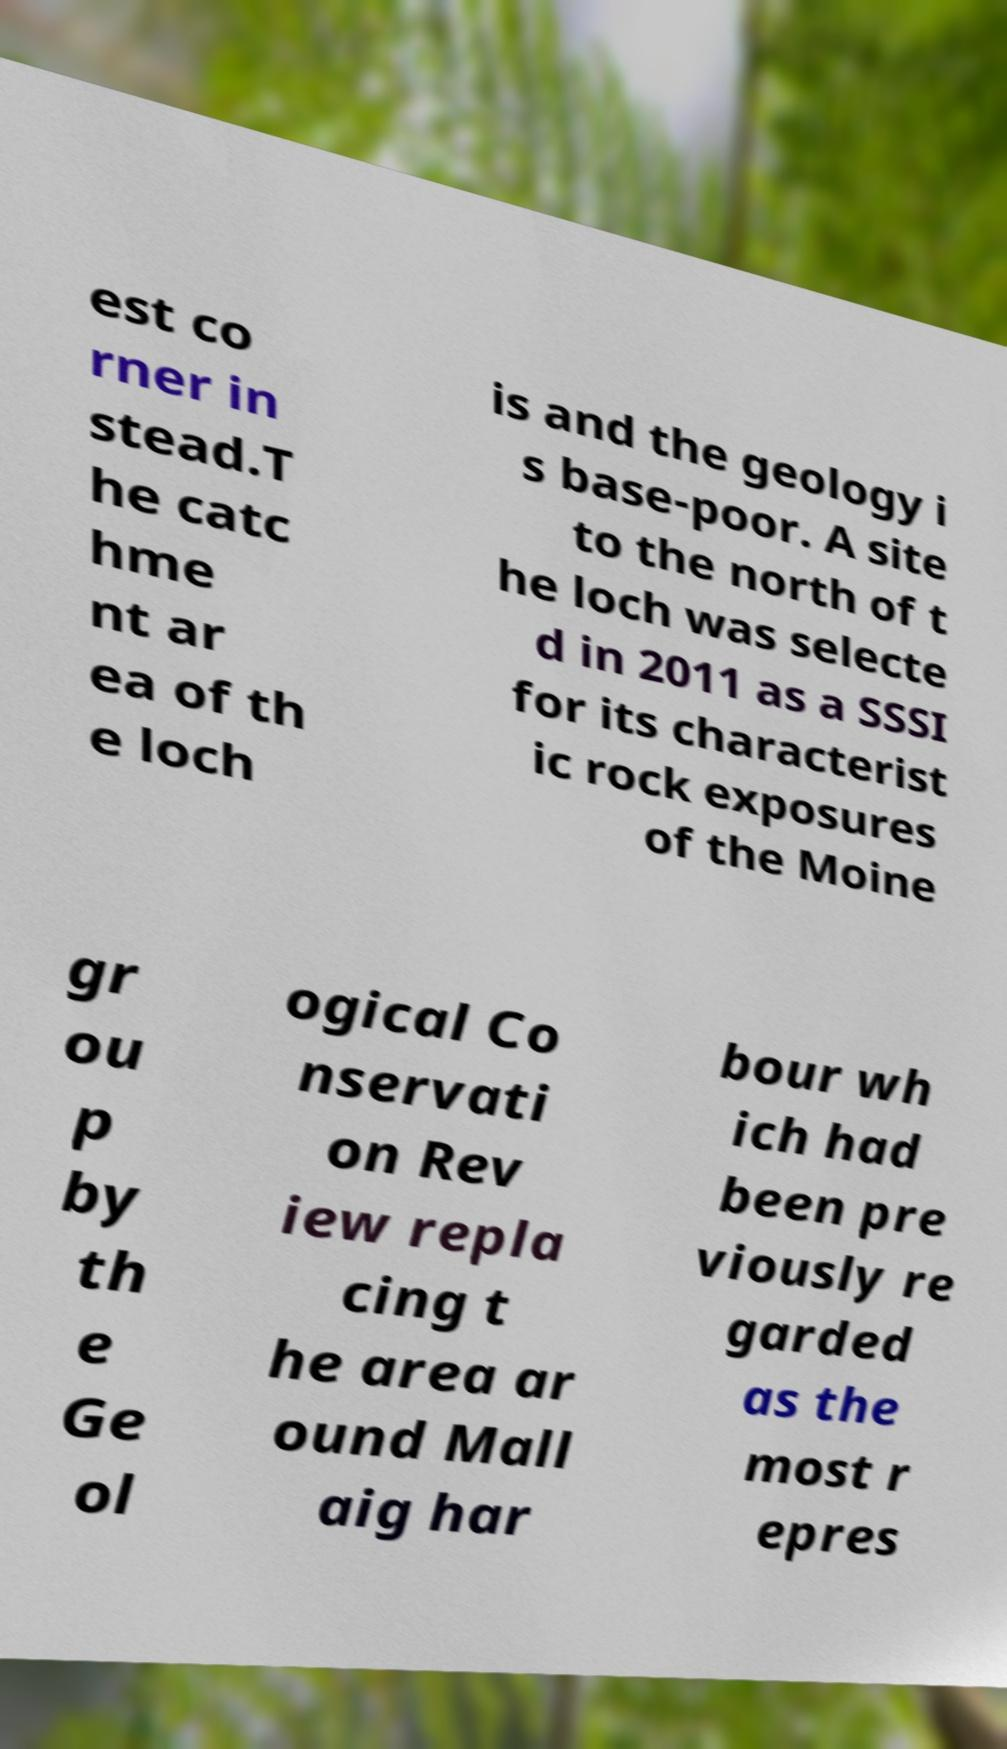For documentation purposes, I need the text within this image transcribed. Could you provide that? est co rner in stead.T he catc hme nt ar ea of th e loch is and the geology i s base-poor. A site to the north of t he loch was selecte d in 2011 as a SSSI for its characterist ic rock exposures of the Moine gr ou p by th e Ge ol ogical Co nservati on Rev iew repla cing t he area ar ound Mall aig har bour wh ich had been pre viously re garded as the most r epres 